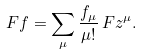Convert formula to latex. <formula><loc_0><loc_0><loc_500><loc_500>F f = \sum _ { \mu } \frac { f _ { \mu } } { \mu ! } \, F z ^ { \mu } .</formula> 